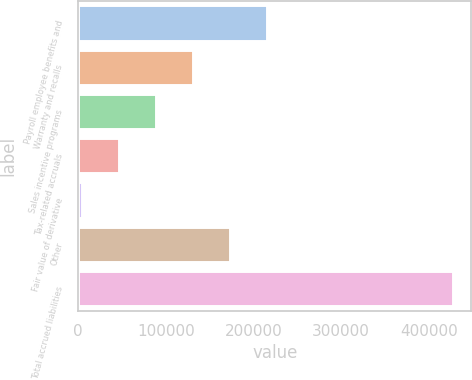<chart> <loc_0><loc_0><loc_500><loc_500><bar_chart><fcel>Payroll employee benefits and<fcel>Warranty and recalls<fcel>Sales incentive programs<fcel>Tax-related accruals<fcel>Fair value of derivative<fcel>Other<fcel>Total accrued liabilities<nl><fcel>215630<fcel>130948<fcel>88607<fcel>46266<fcel>3925<fcel>173289<fcel>427335<nl></chart> 